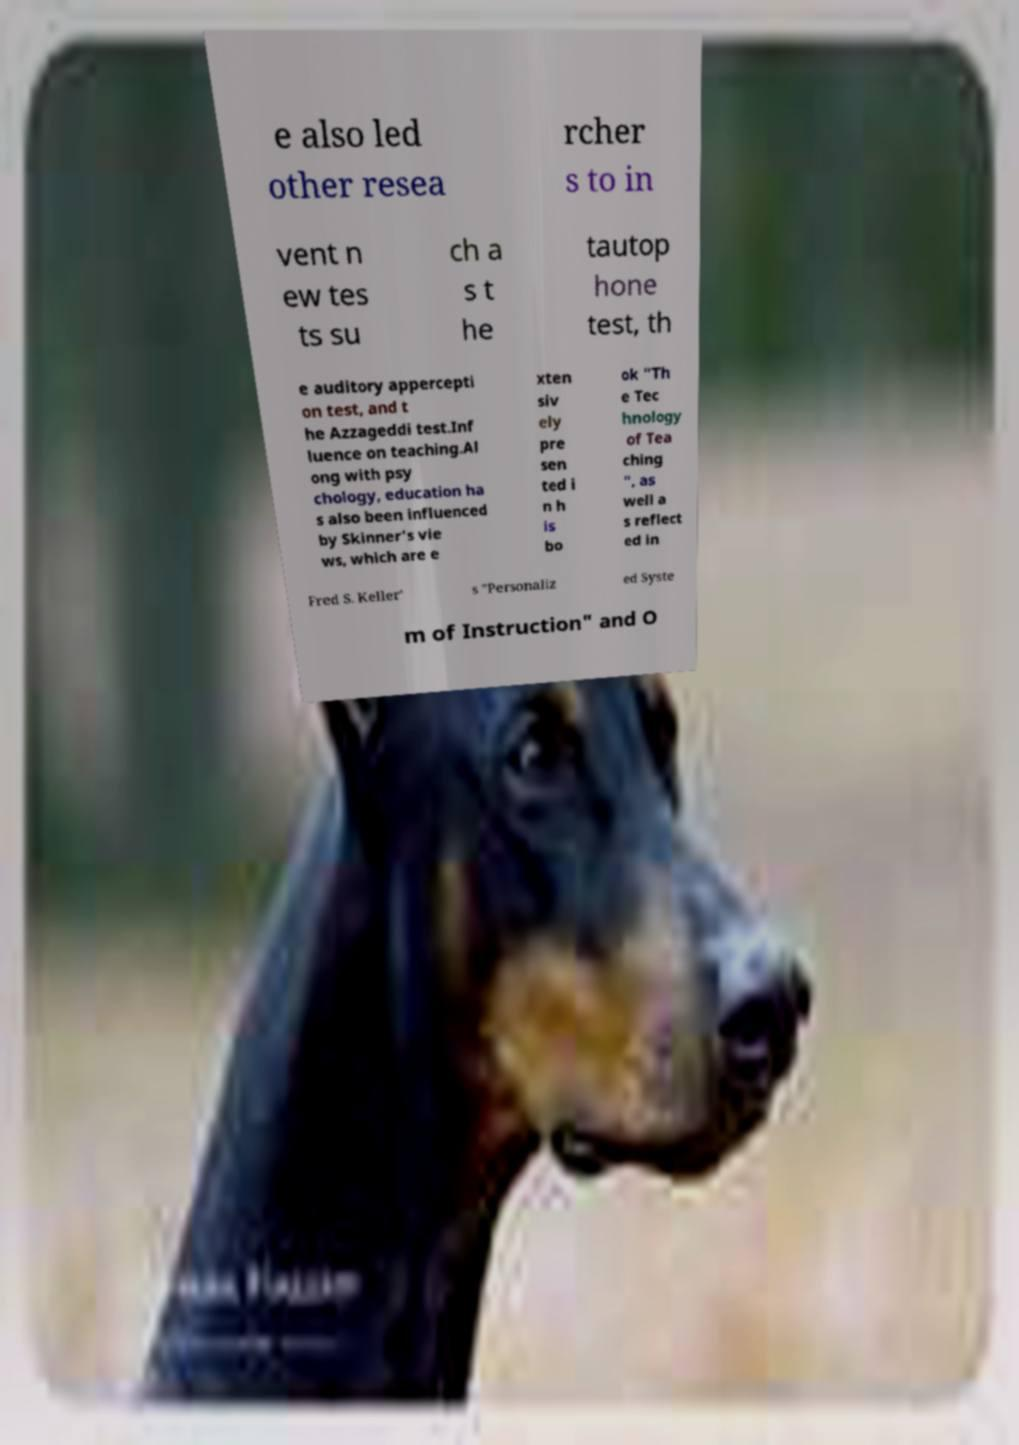Could you extract and type out the text from this image? e also led other resea rcher s to in vent n ew tes ts su ch a s t he tautop hone test, th e auditory appercepti on test, and t he Azzageddi test.Inf luence on teaching.Al ong with psy chology, education ha s also been influenced by Skinner's vie ws, which are e xten siv ely pre sen ted i n h is bo ok "Th e Tec hnology of Tea ching ", as well a s reflect ed in Fred S. Keller' s "Personaliz ed Syste m of Instruction" and O 